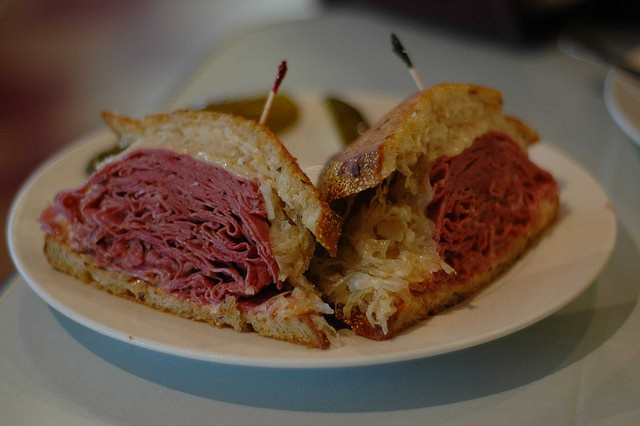Describe the objects in this image and their specific colors. I can see dining table in gray, maroon, and olive tones, sandwich in maroon, gray, and brown tones, and sandwich in maroon, black, and olive tones in this image. 